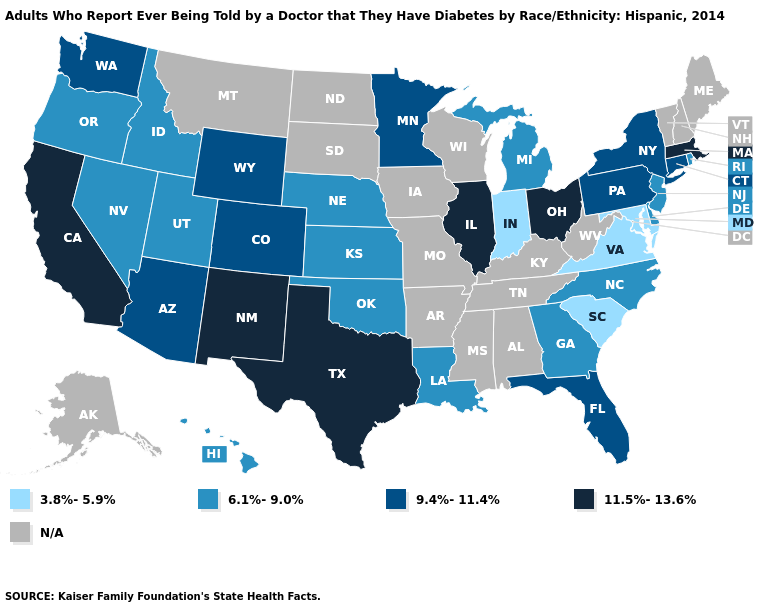Name the states that have a value in the range 9.4%-11.4%?
Concise answer only. Arizona, Colorado, Connecticut, Florida, Minnesota, New York, Pennsylvania, Washington, Wyoming. Name the states that have a value in the range N/A?
Quick response, please. Alabama, Alaska, Arkansas, Iowa, Kentucky, Maine, Mississippi, Missouri, Montana, New Hampshire, North Dakota, South Dakota, Tennessee, Vermont, West Virginia, Wisconsin. What is the value of Oregon?
Concise answer only. 6.1%-9.0%. Name the states that have a value in the range 3.8%-5.9%?
Be succinct. Indiana, Maryland, South Carolina, Virginia. What is the highest value in states that border Arizona?
Answer briefly. 11.5%-13.6%. Which states have the highest value in the USA?
Keep it brief. California, Illinois, Massachusetts, New Mexico, Ohio, Texas. What is the value of Oregon?
Keep it brief. 6.1%-9.0%. What is the value of Vermont?
Be succinct. N/A. Name the states that have a value in the range N/A?
Quick response, please. Alabama, Alaska, Arkansas, Iowa, Kentucky, Maine, Mississippi, Missouri, Montana, New Hampshire, North Dakota, South Dakota, Tennessee, Vermont, West Virginia, Wisconsin. What is the value of Georgia?
Write a very short answer. 6.1%-9.0%. Name the states that have a value in the range 3.8%-5.9%?
Short answer required. Indiana, Maryland, South Carolina, Virginia. Name the states that have a value in the range 11.5%-13.6%?
Keep it brief. California, Illinois, Massachusetts, New Mexico, Ohio, Texas. What is the value of Rhode Island?
Write a very short answer. 6.1%-9.0%. Name the states that have a value in the range 9.4%-11.4%?
Give a very brief answer. Arizona, Colorado, Connecticut, Florida, Minnesota, New York, Pennsylvania, Washington, Wyoming. 